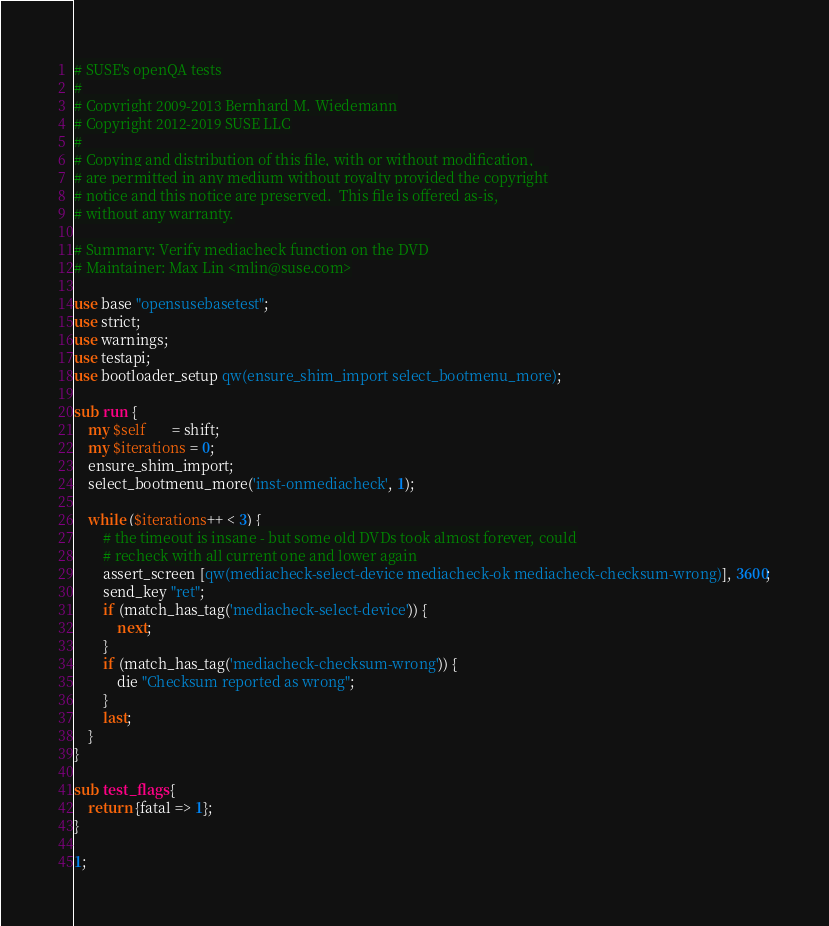Convert code to text. <code><loc_0><loc_0><loc_500><loc_500><_Perl_># SUSE's openQA tests
#
# Copyright 2009-2013 Bernhard M. Wiedemann
# Copyright 2012-2019 SUSE LLC
#
# Copying and distribution of this file, with or without modification,
# are permitted in any medium without royalty provided the copyright
# notice and this notice are preserved.  This file is offered as-is,
# without any warranty.

# Summary: Verify mediacheck function on the DVD
# Maintainer: Max Lin <mlin@suse.com>

use base "opensusebasetest";
use strict;
use warnings;
use testapi;
use bootloader_setup qw(ensure_shim_import select_bootmenu_more);

sub run {
    my $self       = shift;
    my $iterations = 0;
    ensure_shim_import;
    select_bootmenu_more('inst-onmediacheck', 1);

    while ($iterations++ < 3) {
        # the timeout is insane - but some old DVDs took almost forever, could
        # recheck with all current one and lower again
        assert_screen [qw(mediacheck-select-device mediacheck-ok mediacheck-checksum-wrong)], 3600;
        send_key "ret";
        if (match_has_tag('mediacheck-select-device')) {
            next;
        }
        if (match_has_tag('mediacheck-checksum-wrong')) {
            die "Checksum reported as wrong";
        }
        last;
    }
}

sub test_flags {
    return {fatal => 1};
}

1;
</code> 